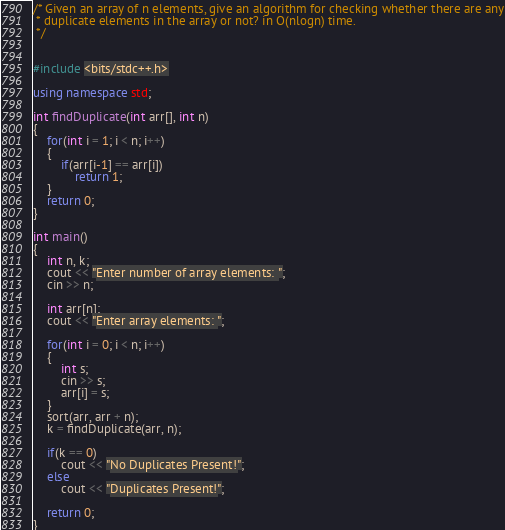Convert code to text. <code><loc_0><loc_0><loc_500><loc_500><_C++_>/* Given an array of n elements, give an algorithm for checking whether there are any
 * duplicate elements in the array or not? in O(nlogn) time.
 */


#include <bits/stdc++.h>

using namespace std;

int findDuplicate(int arr[], int n)
{
    for(int i = 1; i < n; i++)
    {
        if(arr[i-1] == arr[i])
            return 1;
    }
    return 0;
}

int main()
{
    int n, k;
    cout << "Enter number of array elements: ";
    cin >> n;

    int arr[n];
    cout << "Enter array elements: ";

    for(int i = 0; i < n; i++)
    {
        int s;
        cin >> s;
        arr[i] = s;
    }
    sort(arr, arr + n);
    k = findDuplicate(arr, n);

    if(k == 0)
        cout << "No Duplicates Present!";
    else
        cout << "Duplicates Present!";

    return 0;
}
</code> 